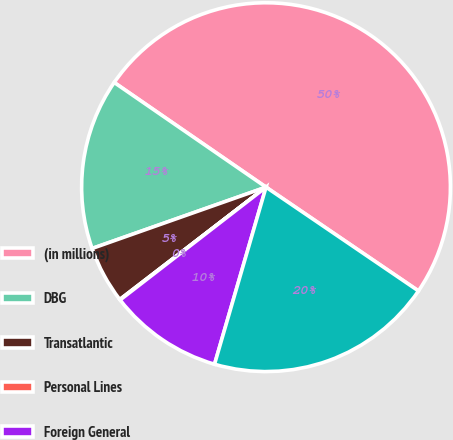<chart> <loc_0><loc_0><loc_500><loc_500><pie_chart><fcel>(in millions)<fcel>DBG<fcel>Transatlantic<fcel>Personal Lines<fcel>Foreign General<fcel>Total<nl><fcel>49.9%<fcel>15.0%<fcel>5.03%<fcel>0.05%<fcel>10.02%<fcel>19.99%<nl></chart> 